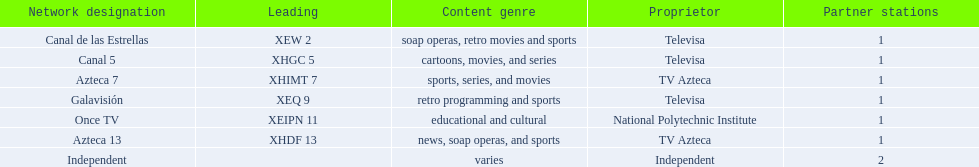Who is the only network owner listed in a consecutive order in the chart? Televisa. 